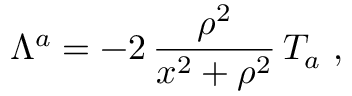Convert formula to latex. <formula><loc_0><loc_0><loc_500><loc_500>\Lambda ^ { a } = - 2 \, \frac { \rho ^ { 2 } } { x ^ { 2 } + \rho ^ { 2 } } \, T _ { a } \ ,</formula> 